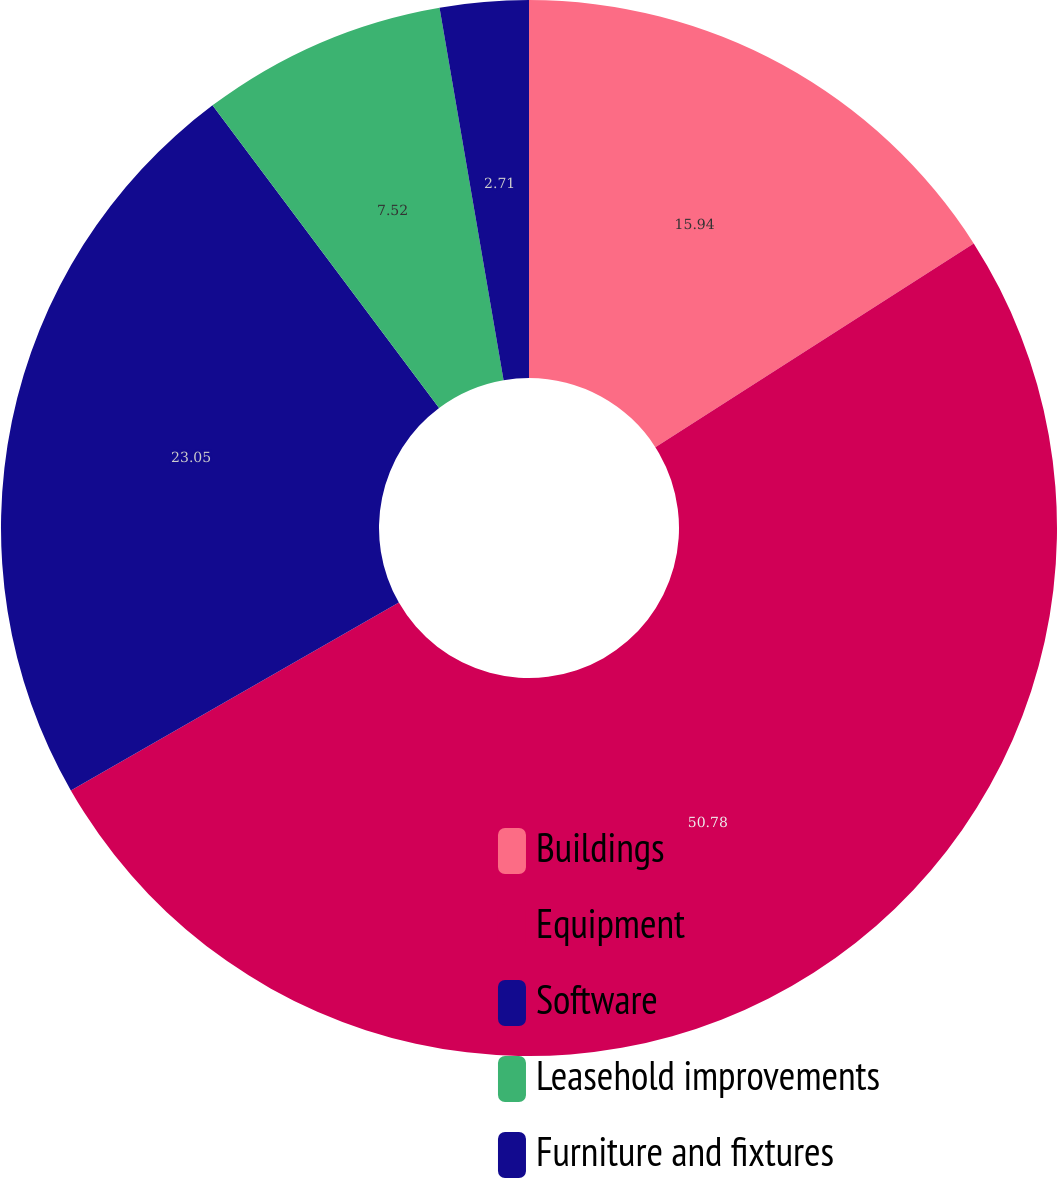Convert chart. <chart><loc_0><loc_0><loc_500><loc_500><pie_chart><fcel>Buildings<fcel>Equipment<fcel>Software<fcel>Leasehold improvements<fcel>Furniture and fixtures<nl><fcel>15.94%<fcel>50.78%<fcel>23.05%<fcel>7.52%<fcel>2.71%<nl></chart> 